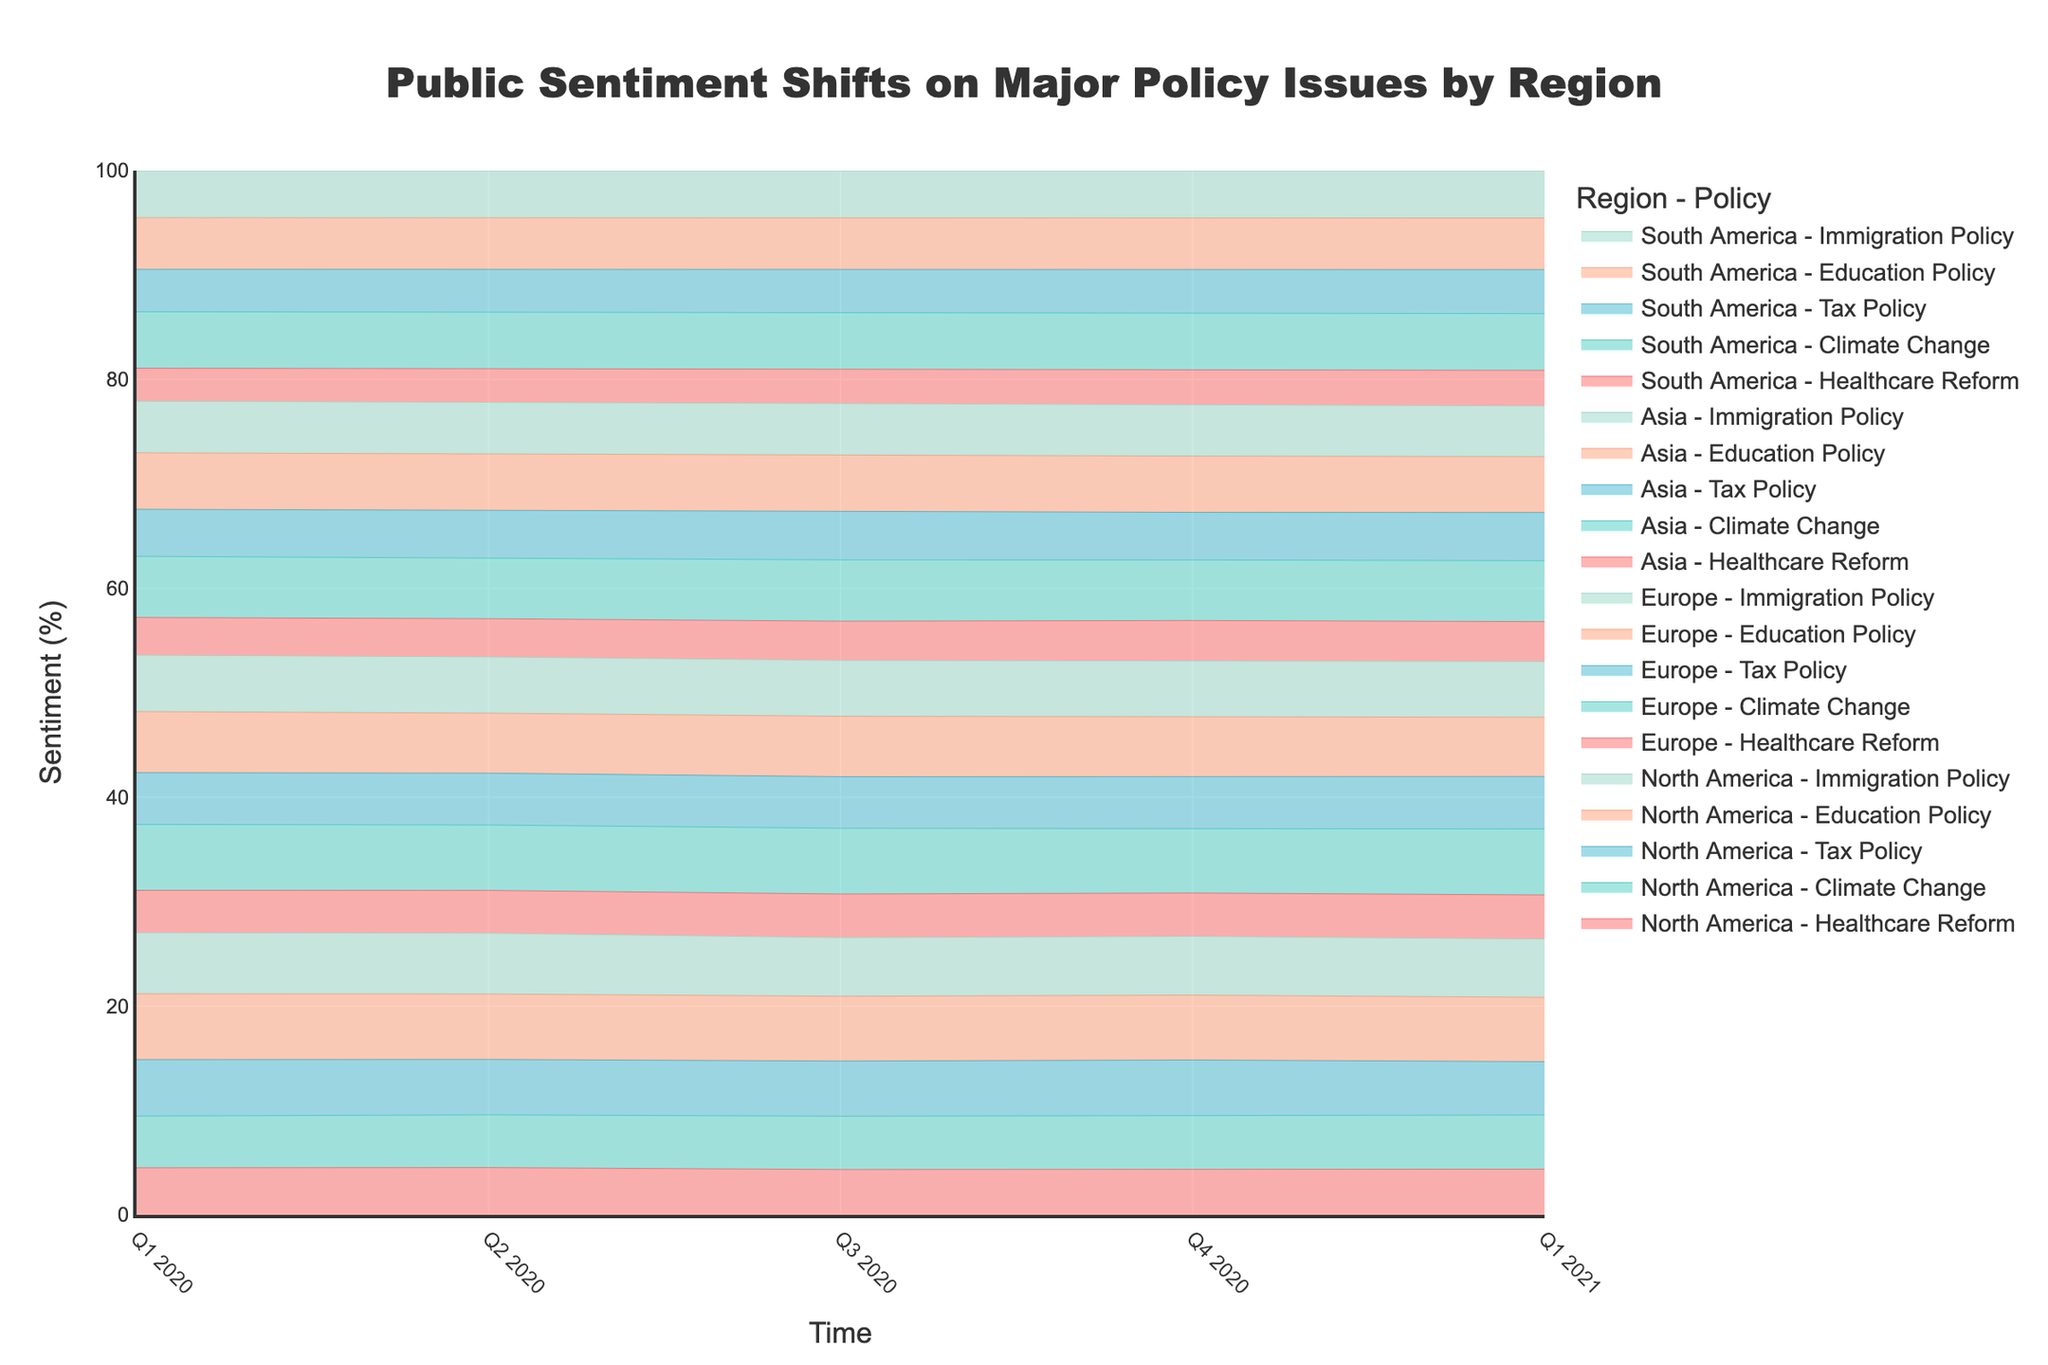What is the title of the chart? The title is located at the top of the chart. It reads "Public Sentiment Shifts on Major Policy Issues by Region". So, the title is clear and concise.
Answer: Public Sentiment Shifts on Major Policy Issues by Region What is the y-axis representing? The y-axis is labeled "Sentiment (%)", indicating that it represents the percentage of public sentiment towards the policy issues over time.
Answer: Sentiment (%) How many geographic regions are represented in the chart? By looking at the legend or the chart, we see the geographic regions labeled along with policies. The regions mentioned are North America, Europe, Asia, and South America.
Answer: Four Which policy had the highest sentiment in Europe in Q1 2021? In Q1 2021 for Europe, the line for "Climate Change" reaches the highest point on the y-axis compared to the other policies.
Answer: Climate Change Comparing Q1 2020 and Q1 2021, which region saw the largest increase in sentiment for Immigration Policy? To answer, compare the sentiment values for Immigration Policy in Q1 2020 and Q1 2021 across all regions. Europe went from 60% to 66%, an increase of 6%. Asia went from 55% to 60%, an increase of 5%. South America went from 50% to 56%, an increase of 6%. North America increased from 65% to 69%, an increase of 4%. Europe and South America both saw an increase of 6%, the largest among the regions.
Answer: Europe and South America What is the trend for Education Policy in North America from Q1 2020 to Q1 2021? Observing the plot, we notice a steady increase in the sentiment for Education Policy in North America from Q1 2020 (70%) to Q1 2021 (76%). The increase year-over-year is consistent across quarters.
Answer: Increasing steadily Which region shows the most significant change in sentiment for Climate Change over the entire time period? By examining the sentiment lines for Climate Change in each region across the entire time period, Europe stands out with a sentiment increase from 70% in Q1 2020 to 78% in Q1 2021, the highest increase compared to other regions.
Answer: Europe On average, which policy issue shows the highest sentiment across all regions in Q1 2021? Calculate the average sentiment for each policy issue in Q1 2021 across all regions. The values are:
- Healthcare Reform: (54+52+47+42) / 4 = 48.75
- Climate Change: (64+78+72+67) / 4 = 70.25
- Tax Policy: (63+62+57+52) / 4 = 58.5
- Education Policy: (76+70+66+61) / 4 = 68.25
- Immigration Policy: (69+66+60+56) / 4 = 62.75
Comparing the averages, Climate Change has the highest with 70.25.
Answer: Climate Change Which policy in Asia had the lowest sentiment in Q4 2020 and what was the value? In Q4 2020 for the Asia region, examining the sentiment values, the lowest is for Tax Policy at 55%.
Answer: Tax Policy, 55% 